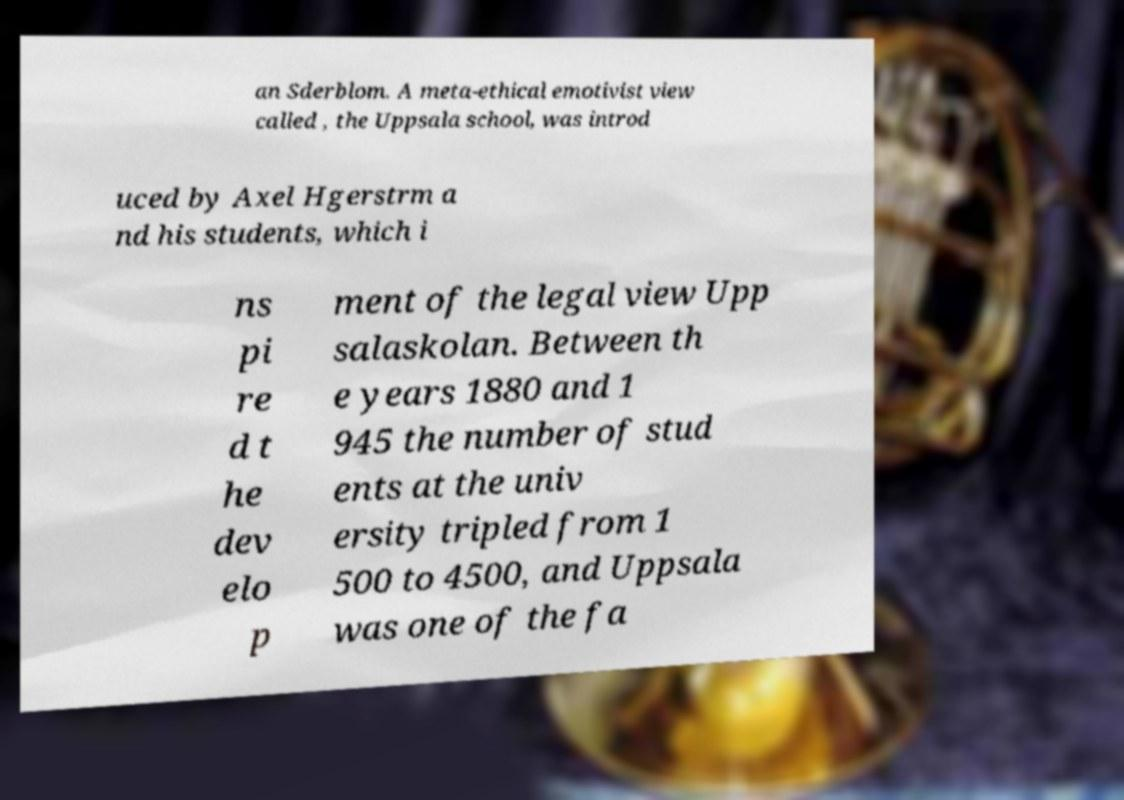Please identify and transcribe the text found in this image. an Sderblom. A meta-ethical emotivist view called , the Uppsala school, was introd uced by Axel Hgerstrm a nd his students, which i ns pi re d t he dev elo p ment of the legal view Upp salaskolan. Between th e years 1880 and 1 945 the number of stud ents at the univ ersity tripled from 1 500 to 4500, and Uppsala was one of the fa 